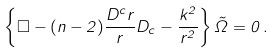<formula> <loc_0><loc_0><loc_500><loc_500>\left \{ \Box - ( n - 2 ) \frac { D ^ { c } r } { r } D _ { c } - \frac { k ^ { 2 } } { r ^ { 2 } } \right \} \tilde { \Omega } = 0 \, .</formula> 